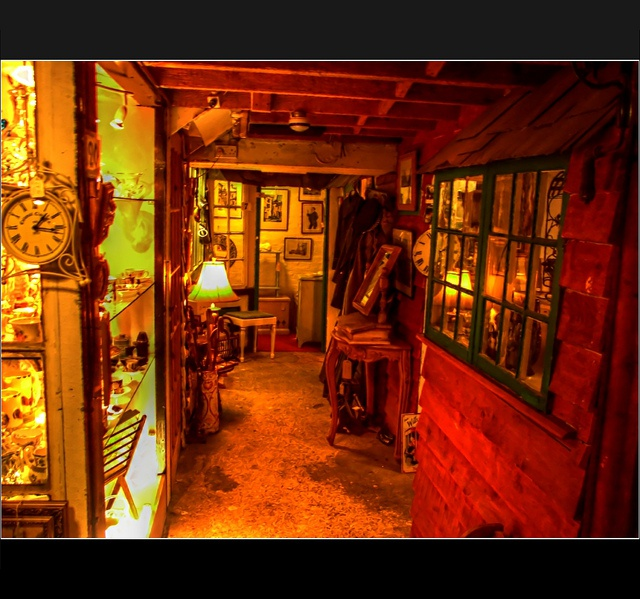Describe the objects in this image and their specific colors. I can see clock in black, orange, brown, and maroon tones, chair in black, maroon, orange, yellow, and brown tones, clock in black, red, maroon, and brown tones, cup in black, red, orange, maroon, and brown tones, and bowl in black, orange, gold, and red tones in this image. 